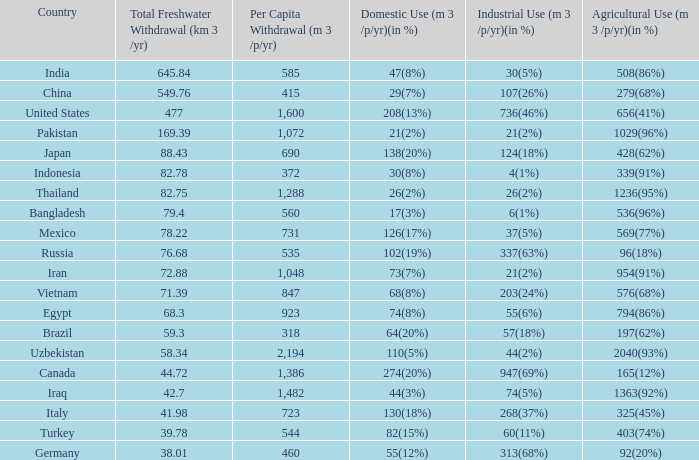Considering a 1363 (92%) agricultural use (m3/p/ None. 